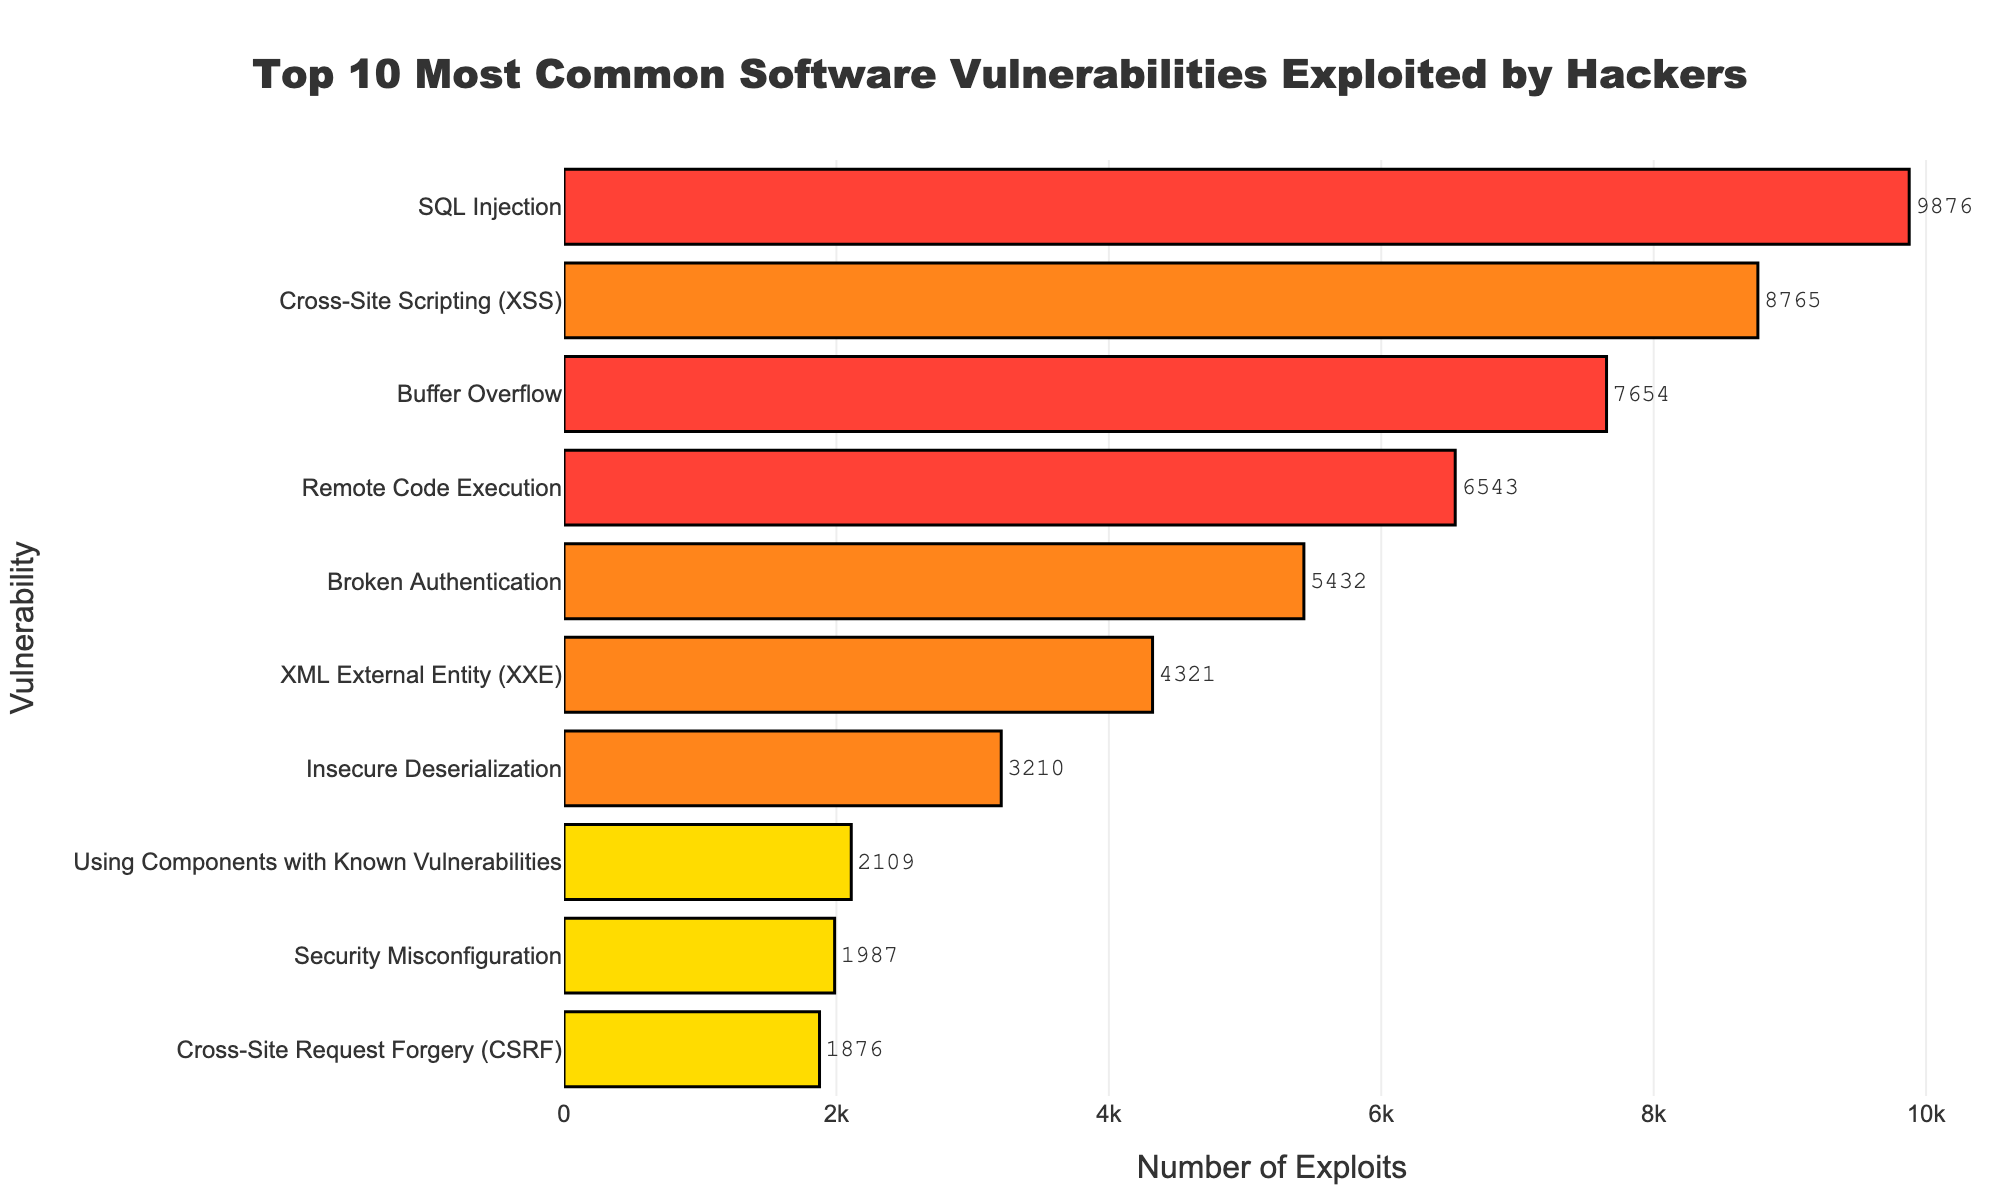What's the most exploited vulnerability? The bar representing SQL Injection is the longest, indicating it has the highest number of exploits.
Answer: SQL Injection Which vulnerability has the fewest exploits? The bar representing Cross-Site Request Forgery (CSRF) is the shortest, indicating it has the fewest number of exploits.
Answer: Cross-Site Request Forgery (CSRF) How many vulnerabilities are categorized as "High" severity? The colors for "High" severity vulnerabilities are orange. There are four bars in orange.
Answer: 4 What's the total number of exploits for Critical vulnerabilities? Sum the exploits for SQL Injection (9876), Buffer Overflow (7654), and Remote Code Execution (6543). The total is 9876 + 7654 + 6543 = 24073.
Answer: 24073 What's the difference in the number of exploits between the most and least exploited vulnerabilities? SQL Injection has 9876 exploits, and Cross-Site Request Forgery (CSRF) has 1876. The difference is 9876 - 1876 = 8000.
Answer: 8000 Which "Medium" severity vulnerability has more exploits: Using Components with Known Vulnerabilities or Security Misconfiguration? The bar representing Using Components with Known Vulnerabilities (2109) is longer than Security Misconfiguration (1987).
Answer: Using Components with Known Vulnerabilities How many vulnerabilities have more than 5000 exploits? SQL Injection, Cross-Site Scripting (XSS), Buffer Overflow, Remote Code Execution, and Broken Authentication each have more than 5000 exploits. There are five of them.
Answer: 5 What's the average number of exploits for High severity vulnerabilities? Sum the exploits for Cross-Site Scripting (XSS) (8765), Broken Authentication (5432), XML External Entity (XXE) (4321), and Insecure Deserialization (3210). The total is 8765 + 5432 + 4321 + 3210 = 21728. Divide by 4 to get the average: 21728 / 4 = 5432.
Answer: 5432 What is the combined number of exploits for the two vulnerabilities with the most exploits? SQL Injection (9876) and Cross-Site Scripting (XSS) (8765). Their combined number of exploits is 9876 + 8765 = 18641.
Answer: 18641 